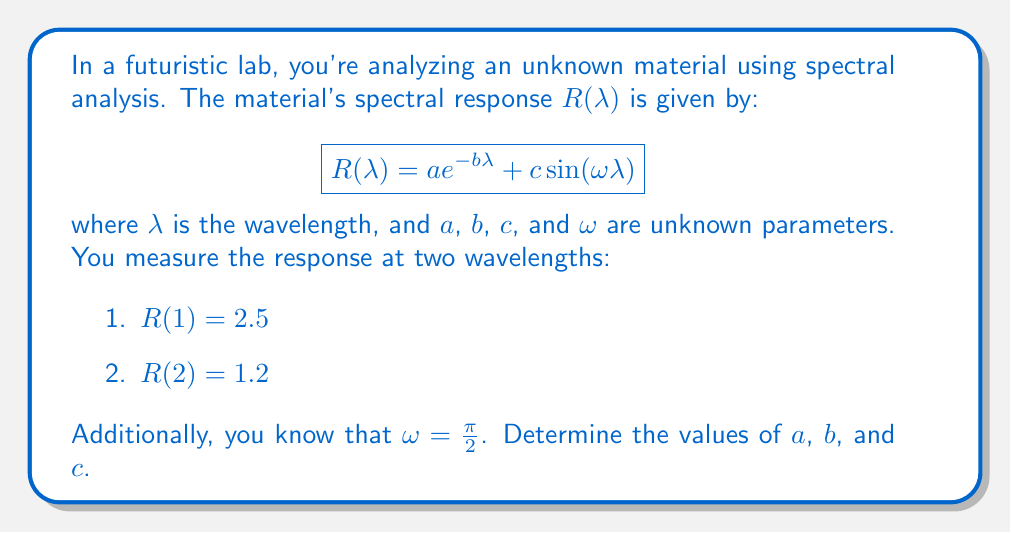Teach me how to tackle this problem. Let's approach this step-by-step:

1) We have two equations based on the given measurements:

   $$2.5 = a e^{-b} + c\sin(\frac{\pi}{2})$$
   $$1.2 = a e^{-2b} + c\sin(\pi)$$

2) Simplify using known trigonometric values:

   $$2.5 = a e^{-b} + c$$
   $$1.2 = a e^{-2b}$$

3) From the second equation:

   $$a = 1.2 e^{2b}$$

4) Substitute this into the first equation:

   $$2.5 = 1.2 e^{2b} e^{-b} + c$$
   $$2.5 = 1.2 e^b + c$$

5) Rearrange:

   $$c = 2.5 - 1.2 e^b$$

6) Now we have expressions for $a$ and $c$ in terms of $b$. We can solve for $b$ numerically using the equation:

   $$1.2 = 1.2 e^b (e^{-2b}) = 1.2 e^{-b}$$

7) Taking the natural log of both sides:

   $$\ln(1) = -b$$
   $$0 = -b$$
   $$b = 0$$

8) Now we can find $a$ and $c$:

   $$a = 1.2 e^{2(0)} = 1.2$$
   $$c = 2.5 - 1.2 e^0 = 1.3$$

Therefore, $a = 1.2$, $b = 0$, and $c = 1.3$.
Answer: $a = 1.2$, $b = 0$, $c = 1.3$ 